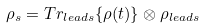Convert formula to latex. <formula><loc_0><loc_0><loc_500><loc_500>\rho _ { s } = T r _ { l e a d s } \{ \rho ( t ) \} \otimes \rho _ { l e a d s }</formula> 